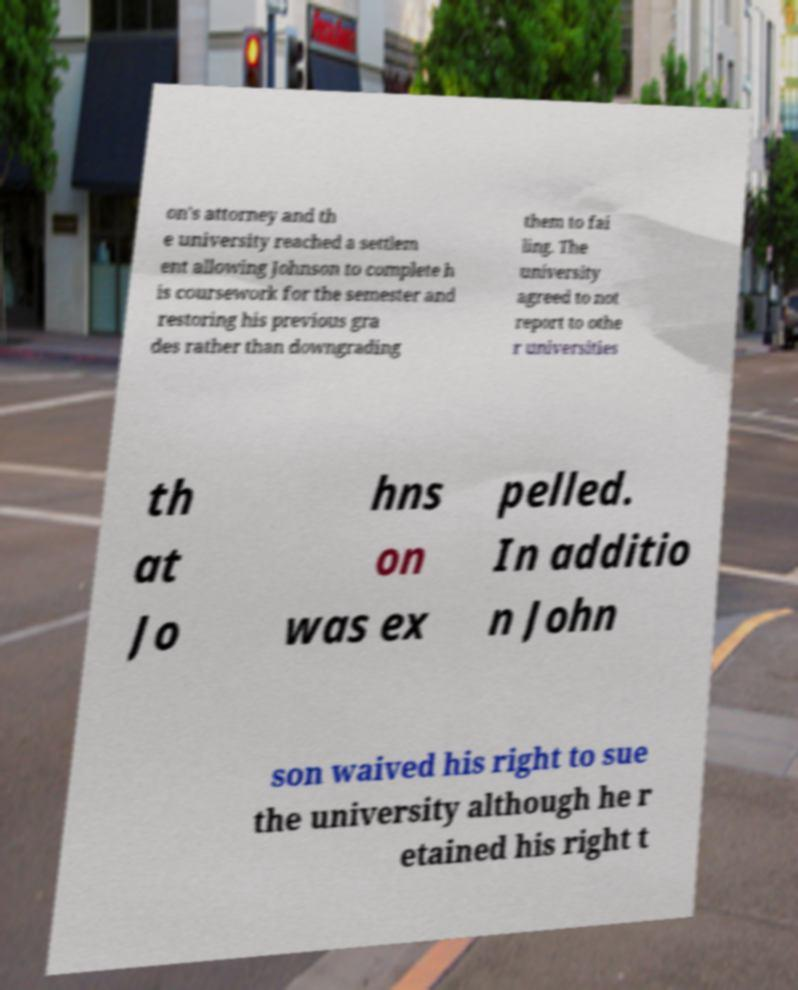Can you read and provide the text displayed in the image?This photo seems to have some interesting text. Can you extract and type it out for me? on's attorney and th e university reached a settlem ent allowing Johnson to complete h is coursework for the semester and restoring his previous gra des rather than downgrading them to fai ling. The university agreed to not report to othe r universities th at Jo hns on was ex pelled. In additio n John son waived his right to sue the university although he r etained his right t 